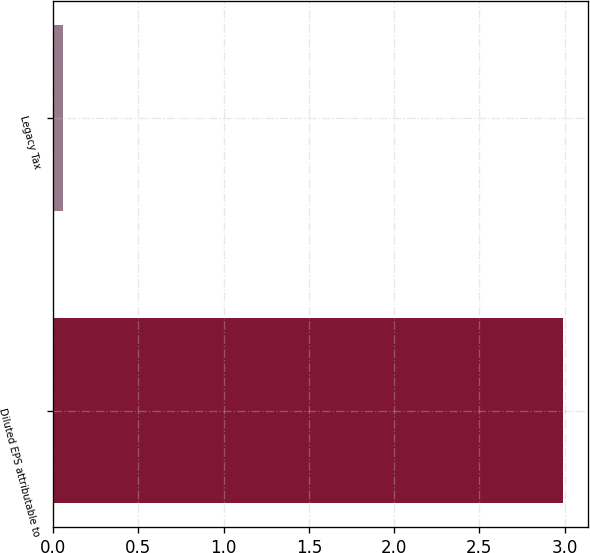<chart> <loc_0><loc_0><loc_500><loc_500><bar_chart><fcel>Diluted EPS attributable to<fcel>Legacy Tax<nl><fcel>2.99<fcel>0.06<nl></chart> 